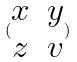<formula> <loc_0><loc_0><loc_500><loc_500>( \begin{matrix} x & y \\ z & v \end{matrix} )</formula> 